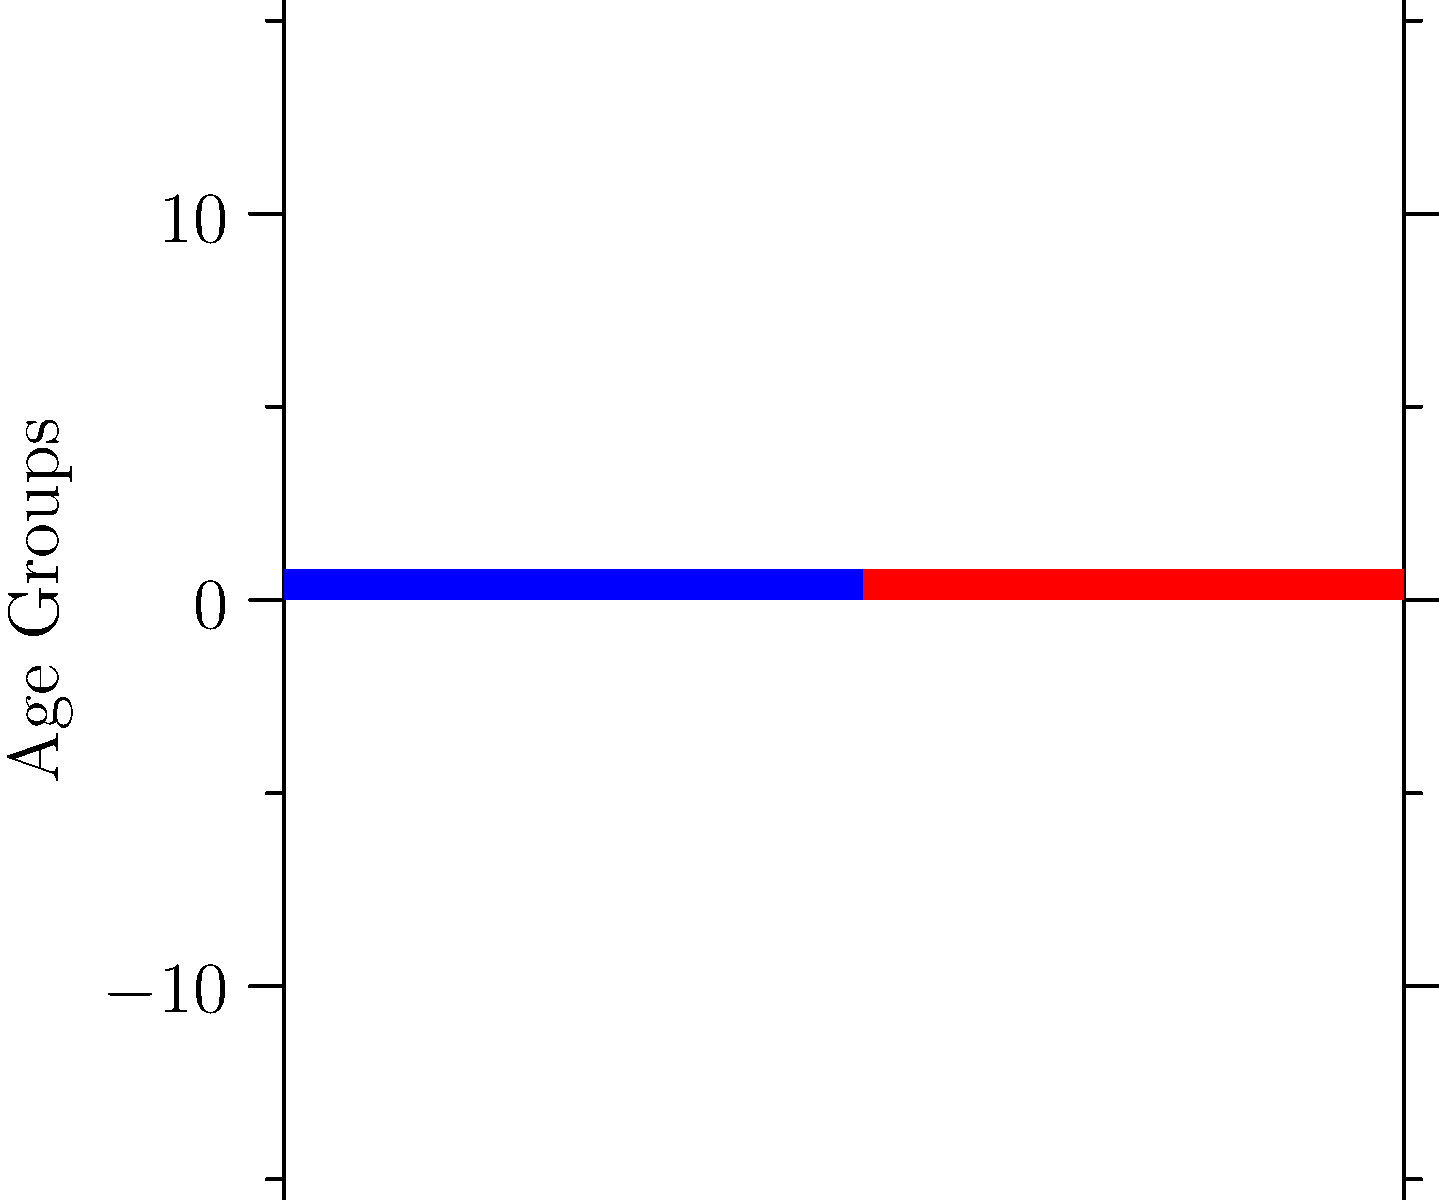As a boutique organic supermarket owner in Guyana, you've collected demographic data on your customers. The population pyramid above represents this data. Which age group shows the highest percentage of both male and female customers, and what strategic decision might you make based on this information? To answer this question, we need to analyze the population pyramid and interpret its implications for the business:

1. Examine the bars for each age group:
   - 0-9: Male ~5%, Female ~6%
   - 10-19: Male ~7%, Female ~8%
   - 20-29: Male ~10%, Female ~11%
   - 30-39: Male ~12%, Female ~13%
   - 40-49: Male ~15%, Female ~14%
   - 50-59: Male ~13%, Female ~12%
   - 60-69: Male ~8%, Female ~7%
   - 70+: Male ~5%, Female ~4%

2. Identify the age group with the highest percentage:
   The 40-49 age group has the highest percentage for both males (15%) and females (14%).

3. Consider the strategic implications:
   - This age group likely represents working professionals with established careers and families.
   - They may have more disposable income to spend on high-quality, organic products.
   - They might be more health-conscious and interested in nutrition.

4. Potential strategic decisions:
   - Focus marketing efforts on health benefits and quality of organic products.
   - Develop product lines that cater to the needs of this age group (e.g., family-sized portions, convenient meal solutions).
   - Create loyalty programs or targeted promotions for this demographic.
   - Adjust store layout and product placement to appeal to this age group.
   - Consider expanding product range to include items that might interest their children or elderly parents.
Answer: 40-49 age group; focus marketing and product development on health-conscious working professionals and families. 